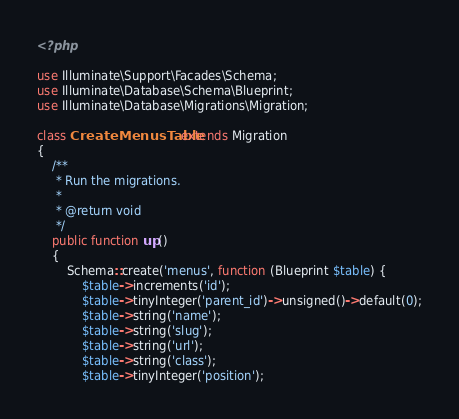<code> <loc_0><loc_0><loc_500><loc_500><_PHP_><?php

use Illuminate\Support\Facades\Schema;
use Illuminate\Database\Schema\Blueprint;
use Illuminate\Database\Migrations\Migration;

class CreateMenusTable extends Migration
{
    /**
     * Run the migrations.
     *
     * @return void
     */
    public function up()
    {
        Schema::create('menus', function (Blueprint $table) {
            $table->increments('id');
            $table->tinyInteger('parent_id')->unsigned()->default(0);
            $table->string('name');
            $table->string('slug');
            $table->string('url');
            $table->string('class');
            $table->tinyInteger('position');</code> 